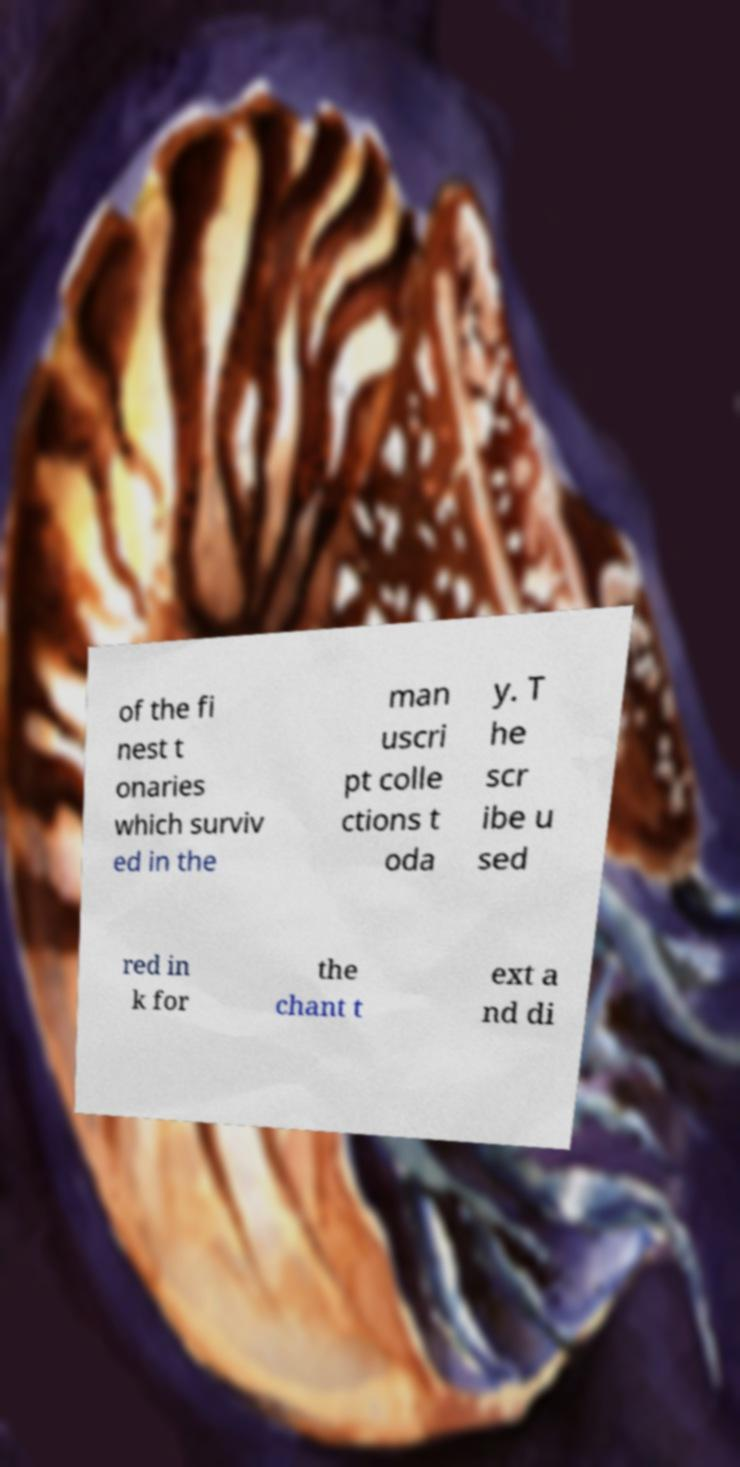For documentation purposes, I need the text within this image transcribed. Could you provide that? of the fi nest t onaries which surviv ed in the man uscri pt colle ctions t oda y. T he scr ibe u sed red in k for the chant t ext a nd di 